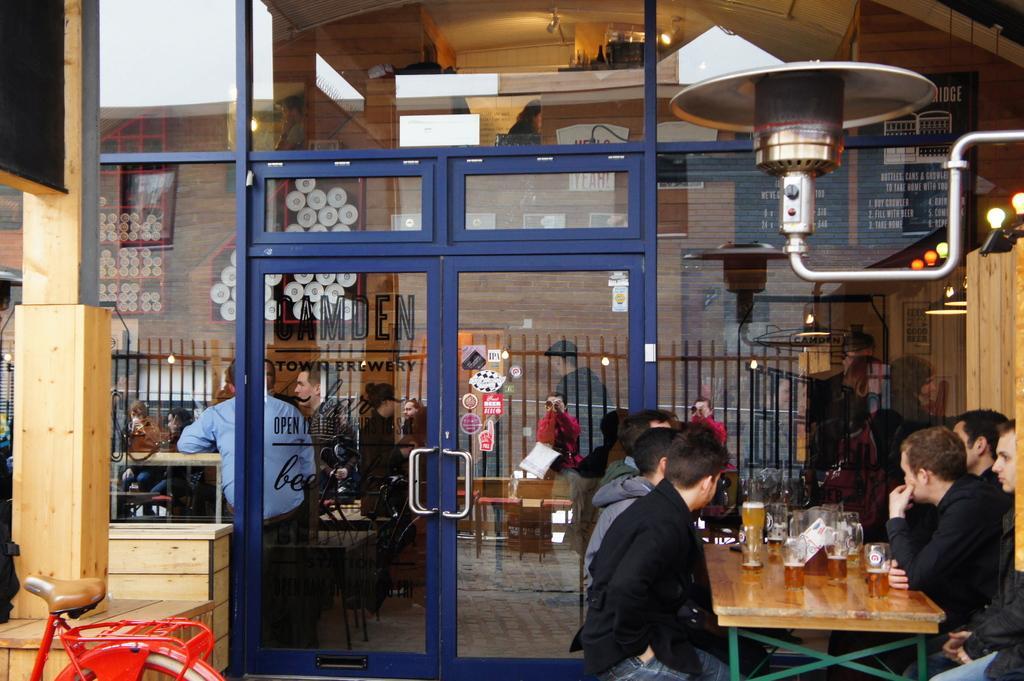Can you describe this image briefly? This is a brewery shop and there are group of people sitting inside and outside, here outside there is group of people sitting with a table and beers in front of them and bottom left side there is bicycle at the right side there are lights, here there is a building and a window, here there is a railing 